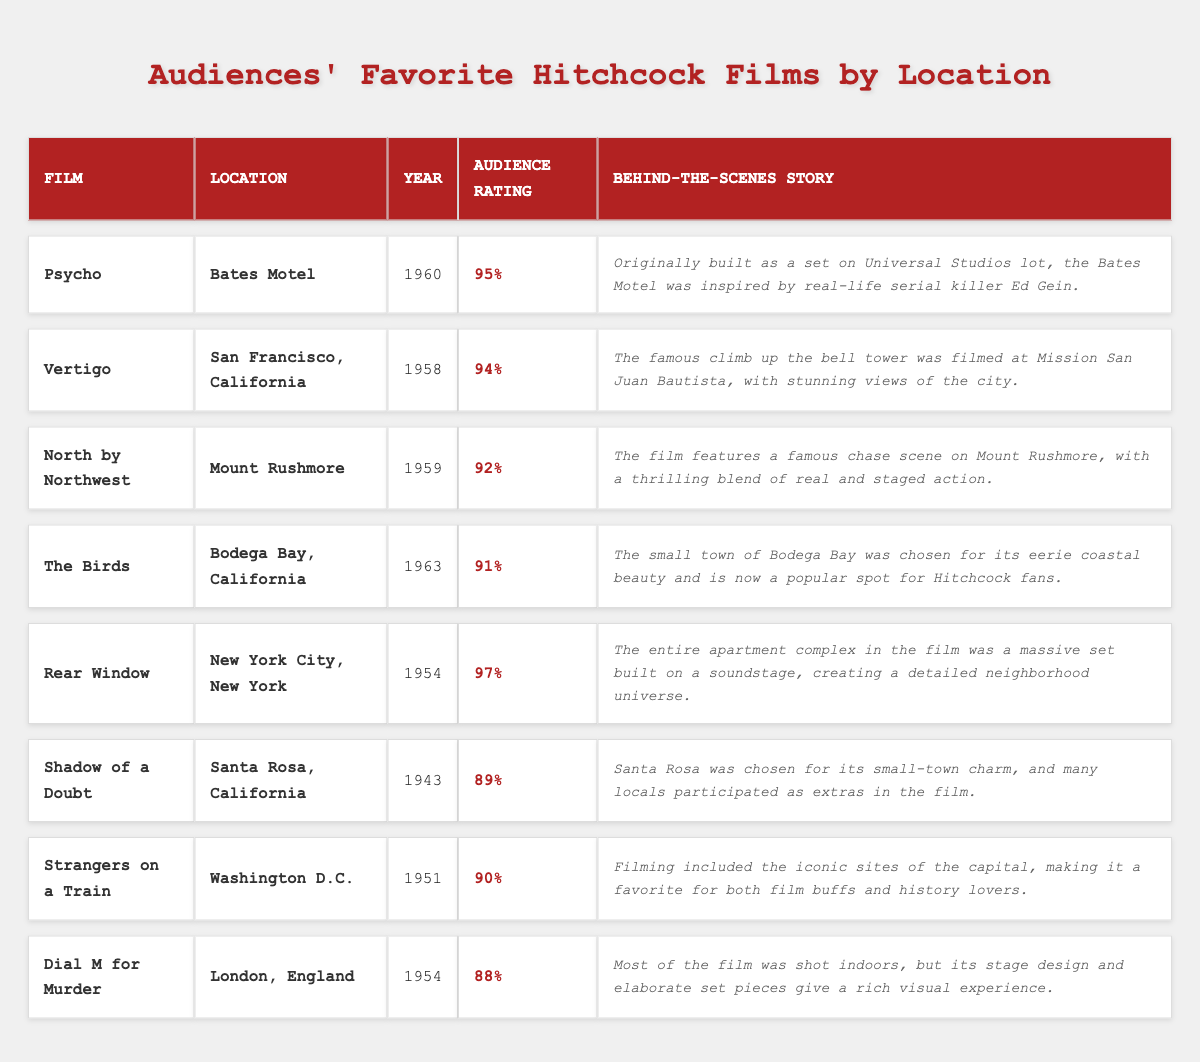What film has the highest audience rating? To find the highest audience rating, look through the audience ratings of all films listed in the table. "Rear Window" has the highest rating of 97%.
Answer: Rear Window Which film was set in London? The location column indicates that "Dial M for Murder" is set in London, England.
Answer: Dial M for Murder What is the audience rating for "Strangers on a Train"? The table shows that "Strangers on a Train" has an audience rating of 90%.
Answer: 90% How many films have an audience rating above 90%? By examining the audience ratings, "Psycho," "Vertigo," "North by Northwest," "Rear Window," and "The Birds" have ratings above 90%. This totals five films.
Answer: 5 Is the filming of "Shadow of a Doubt" associated with Santa Rosa, California? Yes, the location column confirms that "Shadow of a Doubt" was filmed in Santa Rosa, California.
Answer: Yes Which location features a famous chase scene according to the table? "North by Northwest" features a famous chase scene at Mount Rushmore, as mentioned in the behind-the-scenes story.
Answer: Mount Rushmore What year was "The Birds" released? The year column indicates that "The Birds" was released in 1963.
Answer: 1963 What is the average audience rating of the films listed in the table? To find the average, sum the ratings: (95% + 94% + 92% + 91% + 97% + 89% + 90% + 88%) = 736%. There are 8 films, so the average is 736% / 8 = 92%.
Answer: 92% Which film's behind-the-scenes story mentions a serial killer? "Psycho" has a behind-the-scenes story that references the real-life serial killer Ed Gein.
Answer: Psycho Was "Dial M for Murder" filmed mostly outdoors? No, the table's behind-the-scenes story indicates that most of "Dial M for Murder" was shot indoors.
Answer: No 